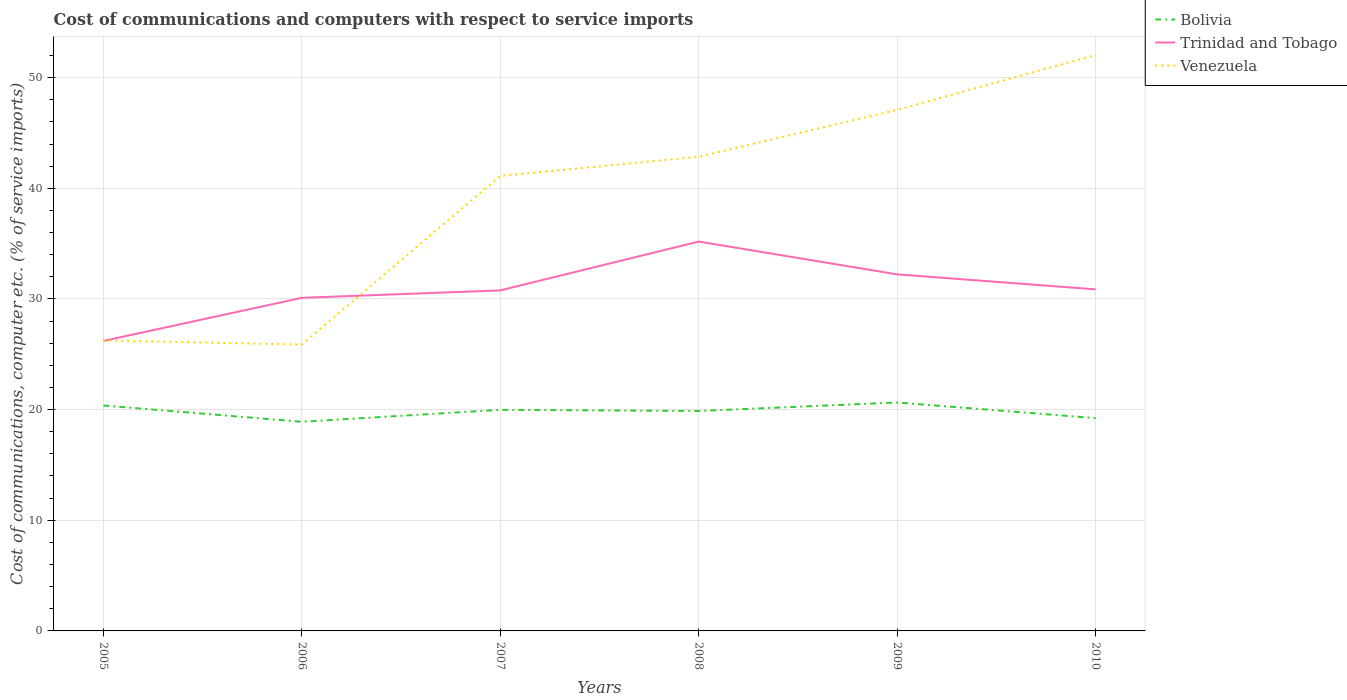Is the number of lines equal to the number of legend labels?
Your response must be concise. Yes. Across all years, what is the maximum cost of communications and computers in Bolivia?
Your answer should be very brief. 18.9. In which year was the cost of communications and computers in Trinidad and Tobago maximum?
Make the answer very short. 2005. What is the total cost of communications and computers in Venezuela in the graph?
Your answer should be very brief. -14.86. What is the difference between the highest and the second highest cost of communications and computers in Venezuela?
Make the answer very short. 26.18. What is the difference between the highest and the lowest cost of communications and computers in Venezuela?
Your answer should be compact. 4. Is the cost of communications and computers in Bolivia strictly greater than the cost of communications and computers in Venezuela over the years?
Keep it short and to the point. Yes. How many years are there in the graph?
Your answer should be compact. 6. What is the difference between two consecutive major ticks on the Y-axis?
Provide a succinct answer. 10. Are the values on the major ticks of Y-axis written in scientific E-notation?
Your answer should be compact. No. Does the graph contain grids?
Keep it short and to the point. Yes. Where does the legend appear in the graph?
Give a very brief answer. Top right. How are the legend labels stacked?
Keep it short and to the point. Vertical. What is the title of the graph?
Make the answer very short. Cost of communications and computers with respect to service imports. Does "Norway" appear as one of the legend labels in the graph?
Provide a short and direct response. No. What is the label or title of the X-axis?
Your response must be concise. Years. What is the label or title of the Y-axis?
Your response must be concise. Cost of communications, computer etc. (% of service imports). What is the Cost of communications, computer etc. (% of service imports) in Bolivia in 2005?
Give a very brief answer. 20.37. What is the Cost of communications, computer etc. (% of service imports) of Trinidad and Tobago in 2005?
Provide a short and direct response. 26.2. What is the Cost of communications, computer etc. (% of service imports) in Venezuela in 2005?
Your answer should be very brief. 26.25. What is the Cost of communications, computer etc. (% of service imports) in Bolivia in 2006?
Ensure brevity in your answer.  18.9. What is the Cost of communications, computer etc. (% of service imports) of Trinidad and Tobago in 2006?
Your answer should be very brief. 30.1. What is the Cost of communications, computer etc. (% of service imports) in Venezuela in 2006?
Your answer should be very brief. 25.88. What is the Cost of communications, computer etc. (% of service imports) in Bolivia in 2007?
Your response must be concise. 19.98. What is the Cost of communications, computer etc. (% of service imports) in Trinidad and Tobago in 2007?
Offer a terse response. 30.77. What is the Cost of communications, computer etc. (% of service imports) of Venezuela in 2007?
Give a very brief answer. 41.11. What is the Cost of communications, computer etc. (% of service imports) of Bolivia in 2008?
Provide a succinct answer. 19.88. What is the Cost of communications, computer etc. (% of service imports) of Trinidad and Tobago in 2008?
Provide a succinct answer. 35.18. What is the Cost of communications, computer etc. (% of service imports) in Venezuela in 2008?
Offer a very short reply. 42.85. What is the Cost of communications, computer etc. (% of service imports) in Bolivia in 2009?
Your answer should be very brief. 20.64. What is the Cost of communications, computer etc. (% of service imports) of Trinidad and Tobago in 2009?
Your response must be concise. 32.22. What is the Cost of communications, computer etc. (% of service imports) of Venezuela in 2009?
Keep it short and to the point. 47.09. What is the Cost of communications, computer etc. (% of service imports) in Bolivia in 2010?
Keep it short and to the point. 19.23. What is the Cost of communications, computer etc. (% of service imports) in Trinidad and Tobago in 2010?
Make the answer very short. 30.87. What is the Cost of communications, computer etc. (% of service imports) in Venezuela in 2010?
Give a very brief answer. 52.05. Across all years, what is the maximum Cost of communications, computer etc. (% of service imports) of Bolivia?
Provide a short and direct response. 20.64. Across all years, what is the maximum Cost of communications, computer etc. (% of service imports) in Trinidad and Tobago?
Offer a terse response. 35.18. Across all years, what is the maximum Cost of communications, computer etc. (% of service imports) of Venezuela?
Your answer should be very brief. 52.05. Across all years, what is the minimum Cost of communications, computer etc. (% of service imports) in Bolivia?
Offer a very short reply. 18.9. Across all years, what is the minimum Cost of communications, computer etc. (% of service imports) of Trinidad and Tobago?
Your response must be concise. 26.2. Across all years, what is the minimum Cost of communications, computer etc. (% of service imports) in Venezuela?
Offer a terse response. 25.88. What is the total Cost of communications, computer etc. (% of service imports) in Bolivia in the graph?
Your response must be concise. 119. What is the total Cost of communications, computer etc. (% of service imports) of Trinidad and Tobago in the graph?
Your response must be concise. 185.35. What is the total Cost of communications, computer etc. (% of service imports) of Venezuela in the graph?
Your answer should be compact. 235.23. What is the difference between the Cost of communications, computer etc. (% of service imports) in Bolivia in 2005 and that in 2006?
Keep it short and to the point. 1.47. What is the difference between the Cost of communications, computer etc. (% of service imports) in Trinidad and Tobago in 2005 and that in 2006?
Offer a very short reply. -3.9. What is the difference between the Cost of communications, computer etc. (% of service imports) in Venezuela in 2005 and that in 2006?
Offer a terse response. 0.37. What is the difference between the Cost of communications, computer etc. (% of service imports) of Bolivia in 2005 and that in 2007?
Your answer should be very brief. 0.39. What is the difference between the Cost of communications, computer etc. (% of service imports) in Trinidad and Tobago in 2005 and that in 2007?
Make the answer very short. -4.57. What is the difference between the Cost of communications, computer etc. (% of service imports) in Venezuela in 2005 and that in 2007?
Ensure brevity in your answer.  -14.86. What is the difference between the Cost of communications, computer etc. (% of service imports) of Bolivia in 2005 and that in 2008?
Your answer should be very brief. 0.5. What is the difference between the Cost of communications, computer etc. (% of service imports) in Trinidad and Tobago in 2005 and that in 2008?
Provide a succinct answer. -8.98. What is the difference between the Cost of communications, computer etc. (% of service imports) of Venezuela in 2005 and that in 2008?
Offer a very short reply. -16.6. What is the difference between the Cost of communications, computer etc. (% of service imports) of Bolivia in 2005 and that in 2009?
Ensure brevity in your answer.  -0.27. What is the difference between the Cost of communications, computer etc. (% of service imports) in Trinidad and Tobago in 2005 and that in 2009?
Give a very brief answer. -6.02. What is the difference between the Cost of communications, computer etc. (% of service imports) in Venezuela in 2005 and that in 2009?
Ensure brevity in your answer.  -20.84. What is the difference between the Cost of communications, computer etc. (% of service imports) of Bolivia in 2005 and that in 2010?
Your answer should be compact. 1.14. What is the difference between the Cost of communications, computer etc. (% of service imports) in Trinidad and Tobago in 2005 and that in 2010?
Your answer should be compact. -4.66. What is the difference between the Cost of communications, computer etc. (% of service imports) in Venezuela in 2005 and that in 2010?
Give a very brief answer. -25.8. What is the difference between the Cost of communications, computer etc. (% of service imports) in Bolivia in 2006 and that in 2007?
Your answer should be compact. -1.08. What is the difference between the Cost of communications, computer etc. (% of service imports) of Trinidad and Tobago in 2006 and that in 2007?
Your answer should be very brief. -0.67. What is the difference between the Cost of communications, computer etc. (% of service imports) in Venezuela in 2006 and that in 2007?
Provide a succinct answer. -15.24. What is the difference between the Cost of communications, computer etc. (% of service imports) in Bolivia in 2006 and that in 2008?
Offer a terse response. -0.98. What is the difference between the Cost of communications, computer etc. (% of service imports) of Trinidad and Tobago in 2006 and that in 2008?
Provide a succinct answer. -5.08. What is the difference between the Cost of communications, computer etc. (% of service imports) in Venezuela in 2006 and that in 2008?
Your response must be concise. -16.98. What is the difference between the Cost of communications, computer etc. (% of service imports) of Bolivia in 2006 and that in 2009?
Make the answer very short. -1.74. What is the difference between the Cost of communications, computer etc. (% of service imports) of Trinidad and Tobago in 2006 and that in 2009?
Offer a terse response. -2.12. What is the difference between the Cost of communications, computer etc. (% of service imports) in Venezuela in 2006 and that in 2009?
Your response must be concise. -21.21. What is the difference between the Cost of communications, computer etc. (% of service imports) of Bolivia in 2006 and that in 2010?
Ensure brevity in your answer.  -0.33. What is the difference between the Cost of communications, computer etc. (% of service imports) in Trinidad and Tobago in 2006 and that in 2010?
Ensure brevity in your answer.  -0.77. What is the difference between the Cost of communications, computer etc. (% of service imports) of Venezuela in 2006 and that in 2010?
Keep it short and to the point. -26.18. What is the difference between the Cost of communications, computer etc. (% of service imports) of Bolivia in 2007 and that in 2008?
Keep it short and to the point. 0.1. What is the difference between the Cost of communications, computer etc. (% of service imports) in Trinidad and Tobago in 2007 and that in 2008?
Make the answer very short. -4.41. What is the difference between the Cost of communications, computer etc. (% of service imports) of Venezuela in 2007 and that in 2008?
Keep it short and to the point. -1.74. What is the difference between the Cost of communications, computer etc. (% of service imports) of Bolivia in 2007 and that in 2009?
Give a very brief answer. -0.66. What is the difference between the Cost of communications, computer etc. (% of service imports) of Trinidad and Tobago in 2007 and that in 2009?
Give a very brief answer. -1.45. What is the difference between the Cost of communications, computer etc. (% of service imports) of Venezuela in 2007 and that in 2009?
Provide a short and direct response. -5.97. What is the difference between the Cost of communications, computer etc. (% of service imports) of Bolivia in 2007 and that in 2010?
Your answer should be compact. 0.75. What is the difference between the Cost of communications, computer etc. (% of service imports) in Trinidad and Tobago in 2007 and that in 2010?
Your answer should be compact. -0.09. What is the difference between the Cost of communications, computer etc. (% of service imports) of Venezuela in 2007 and that in 2010?
Keep it short and to the point. -10.94. What is the difference between the Cost of communications, computer etc. (% of service imports) of Bolivia in 2008 and that in 2009?
Ensure brevity in your answer.  -0.77. What is the difference between the Cost of communications, computer etc. (% of service imports) of Trinidad and Tobago in 2008 and that in 2009?
Your response must be concise. 2.96. What is the difference between the Cost of communications, computer etc. (% of service imports) in Venezuela in 2008 and that in 2009?
Give a very brief answer. -4.23. What is the difference between the Cost of communications, computer etc. (% of service imports) in Bolivia in 2008 and that in 2010?
Give a very brief answer. 0.65. What is the difference between the Cost of communications, computer etc. (% of service imports) of Trinidad and Tobago in 2008 and that in 2010?
Your answer should be very brief. 4.32. What is the difference between the Cost of communications, computer etc. (% of service imports) in Venezuela in 2008 and that in 2010?
Make the answer very short. -9.2. What is the difference between the Cost of communications, computer etc. (% of service imports) of Bolivia in 2009 and that in 2010?
Your response must be concise. 1.41. What is the difference between the Cost of communications, computer etc. (% of service imports) of Trinidad and Tobago in 2009 and that in 2010?
Provide a succinct answer. 1.35. What is the difference between the Cost of communications, computer etc. (% of service imports) of Venezuela in 2009 and that in 2010?
Provide a short and direct response. -4.96. What is the difference between the Cost of communications, computer etc. (% of service imports) in Bolivia in 2005 and the Cost of communications, computer etc. (% of service imports) in Trinidad and Tobago in 2006?
Keep it short and to the point. -9.73. What is the difference between the Cost of communications, computer etc. (% of service imports) in Bolivia in 2005 and the Cost of communications, computer etc. (% of service imports) in Venezuela in 2006?
Give a very brief answer. -5.5. What is the difference between the Cost of communications, computer etc. (% of service imports) of Trinidad and Tobago in 2005 and the Cost of communications, computer etc. (% of service imports) of Venezuela in 2006?
Your answer should be very brief. 0.33. What is the difference between the Cost of communications, computer etc. (% of service imports) of Bolivia in 2005 and the Cost of communications, computer etc. (% of service imports) of Trinidad and Tobago in 2007?
Your answer should be compact. -10.4. What is the difference between the Cost of communications, computer etc. (% of service imports) of Bolivia in 2005 and the Cost of communications, computer etc. (% of service imports) of Venezuela in 2007?
Make the answer very short. -20.74. What is the difference between the Cost of communications, computer etc. (% of service imports) of Trinidad and Tobago in 2005 and the Cost of communications, computer etc. (% of service imports) of Venezuela in 2007?
Provide a succinct answer. -14.91. What is the difference between the Cost of communications, computer etc. (% of service imports) in Bolivia in 2005 and the Cost of communications, computer etc. (% of service imports) in Trinidad and Tobago in 2008?
Keep it short and to the point. -14.81. What is the difference between the Cost of communications, computer etc. (% of service imports) of Bolivia in 2005 and the Cost of communications, computer etc. (% of service imports) of Venezuela in 2008?
Give a very brief answer. -22.48. What is the difference between the Cost of communications, computer etc. (% of service imports) of Trinidad and Tobago in 2005 and the Cost of communications, computer etc. (% of service imports) of Venezuela in 2008?
Provide a short and direct response. -16.65. What is the difference between the Cost of communications, computer etc. (% of service imports) in Bolivia in 2005 and the Cost of communications, computer etc. (% of service imports) in Trinidad and Tobago in 2009?
Your answer should be very brief. -11.85. What is the difference between the Cost of communications, computer etc. (% of service imports) in Bolivia in 2005 and the Cost of communications, computer etc. (% of service imports) in Venezuela in 2009?
Give a very brief answer. -26.71. What is the difference between the Cost of communications, computer etc. (% of service imports) in Trinidad and Tobago in 2005 and the Cost of communications, computer etc. (% of service imports) in Venezuela in 2009?
Give a very brief answer. -20.88. What is the difference between the Cost of communications, computer etc. (% of service imports) of Bolivia in 2005 and the Cost of communications, computer etc. (% of service imports) of Trinidad and Tobago in 2010?
Provide a short and direct response. -10.49. What is the difference between the Cost of communications, computer etc. (% of service imports) of Bolivia in 2005 and the Cost of communications, computer etc. (% of service imports) of Venezuela in 2010?
Offer a very short reply. -31.68. What is the difference between the Cost of communications, computer etc. (% of service imports) in Trinidad and Tobago in 2005 and the Cost of communications, computer etc. (% of service imports) in Venezuela in 2010?
Your answer should be very brief. -25.85. What is the difference between the Cost of communications, computer etc. (% of service imports) of Bolivia in 2006 and the Cost of communications, computer etc. (% of service imports) of Trinidad and Tobago in 2007?
Your answer should be very brief. -11.87. What is the difference between the Cost of communications, computer etc. (% of service imports) of Bolivia in 2006 and the Cost of communications, computer etc. (% of service imports) of Venezuela in 2007?
Provide a succinct answer. -22.21. What is the difference between the Cost of communications, computer etc. (% of service imports) in Trinidad and Tobago in 2006 and the Cost of communications, computer etc. (% of service imports) in Venezuela in 2007?
Keep it short and to the point. -11.01. What is the difference between the Cost of communications, computer etc. (% of service imports) in Bolivia in 2006 and the Cost of communications, computer etc. (% of service imports) in Trinidad and Tobago in 2008?
Provide a succinct answer. -16.28. What is the difference between the Cost of communications, computer etc. (% of service imports) in Bolivia in 2006 and the Cost of communications, computer etc. (% of service imports) in Venezuela in 2008?
Offer a very short reply. -23.95. What is the difference between the Cost of communications, computer etc. (% of service imports) in Trinidad and Tobago in 2006 and the Cost of communications, computer etc. (% of service imports) in Venezuela in 2008?
Offer a very short reply. -12.75. What is the difference between the Cost of communications, computer etc. (% of service imports) of Bolivia in 2006 and the Cost of communications, computer etc. (% of service imports) of Trinidad and Tobago in 2009?
Your answer should be very brief. -13.32. What is the difference between the Cost of communications, computer etc. (% of service imports) of Bolivia in 2006 and the Cost of communications, computer etc. (% of service imports) of Venezuela in 2009?
Make the answer very short. -28.19. What is the difference between the Cost of communications, computer etc. (% of service imports) in Trinidad and Tobago in 2006 and the Cost of communications, computer etc. (% of service imports) in Venezuela in 2009?
Your answer should be compact. -16.99. What is the difference between the Cost of communications, computer etc. (% of service imports) in Bolivia in 2006 and the Cost of communications, computer etc. (% of service imports) in Trinidad and Tobago in 2010?
Offer a very short reply. -11.97. What is the difference between the Cost of communications, computer etc. (% of service imports) of Bolivia in 2006 and the Cost of communications, computer etc. (% of service imports) of Venezuela in 2010?
Provide a succinct answer. -33.15. What is the difference between the Cost of communications, computer etc. (% of service imports) in Trinidad and Tobago in 2006 and the Cost of communications, computer etc. (% of service imports) in Venezuela in 2010?
Ensure brevity in your answer.  -21.95. What is the difference between the Cost of communications, computer etc. (% of service imports) of Bolivia in 2007 and the Cost of communications, computer etc. (% of service imports) of Trinidad and Tobago in 2008?
Your answer should be very brief. -15.21. What is the difference between the Cost of communications, computer etc. (% of service imports) of Bolivia in 2007 and the Cost of communications, computer etc. (% of service imports) of Venezuela in 2008?
Your response must be concise. -22.87. What is the difference between the Cost of communications, computer etc. (% of service imports) in Trinidad and Tobago in 2007 and the Cost of communications, computer etc. (% of service imports) in Venezuela in 2008?
Your answer should be compact. -12.08. What is the difference between the Cost of communications, computer etc. (% of service imports) in Bolivia in 2007 and the Cost of communications, computer etc. (% of service imports) in Trinidad and Tobago in 2009?
Offer a very short reply. -12.24. What is the difference between the Cost of communications, computer etc. (% of service imports) of Bolivia in 2007 and the Cost of communications, computer etc. (% of service imports) of Venezuela in 2009?
Offer a terse response. -27.11. What is the difference between the Cost of communications, computer etc. (% of service imports) of Trinidad and Tobago in 2007 and the Cost of communications, computer etc. (% of service imports) of Venezuela in 2009?
Give a very brief answer. -16.31. What is the difference between the Cost of communications, computer etc. (% of service imports) of Bolivia in 2007 and the Cost of communications, computer etc. (% of service imports) of Trinidad and Tobago in 2010?
Give a very brief answer. -10.89. What is the difference between the Cost of communications, computer etc. (% of service imports) in Bolivia in 2007 and the Cost of communications, computer etc. (% of service imports) in Venezuela in 2010?
Offer a very short reply. -32.07. What is the difference between the Cost of communications, computer etc. (% of service imports) in Trinidad and Tobago in 2007 and the Cost of communications, computer etc. (% of service imports) in Venezuela in 2010?
Your response must be concise. -21.28. What is the difference between the Cost of communications, computer etc. (% of service imports) of Bolivia in 2008 and the Cost of communications, computer etc. (% of service imports) of Trinidad and Tobago in 2009?
Provide a succinct answer. -12.34. What is the difference between the Cost of communications, computer etc. (% of service imports) in Bolivia in 2008 and the Cost of communications, computer etc. (% of service imports) in Venezuela in 2009?
Your answer should be very brief. -27.21. What is the difference between the Cost of communications, computer etc. (% of service imports) of Trinidad and Tobago in 2008 and the Cost of communications, computer etc. (% of service imports) of Venezuela in 2009?
Your answer should be very brief. -11.9. What is the difference between the Cost of communications, computer etc. (% of service imports) of Bolivia in 2008 and the Cost of communications, computer etc. (% of service imports) of Trinidad and Tobago in 2010?
Your answer should be very brief. -10.99. What is the difference between the Cost of communications, computer etc. (% of service imports) of Bolivia in 2008 and the Cost of communications, computer etc. (% of service imports) of Venezuela in 2010?
Offer a terse response. -32.18. What is the difference between the Cost of communications, computer etc. (% of service imports) of Trinidad and Tobago in 2008 and the Cost of communications, computer etc. (% of service imports) of Venezuela in 2010?
Your answer should be compact. -16.87. What is the difference between the Cost of communications, computer etc. (% of service imports) of Bolivia in 2009 and the Cost of communications, computer etc. (% of service imports) of Trinidad and Tobago in 2010?
Provide a short and direct response. -10.22. What is the difference between the Cost of communications, computer etc. (% of service imports) of Bolivia in 2009 and the Cost of communications, computer etc. (% of service imports) of Venezuela in 2010?
Provide a succinct answer. -31.41. What is the difference between the Cost of communications, computer etc. (% of service imports) of Trinidad and Tobago in 2009 and the Cost of communications, computer etc. (% of service imports) of Venezuela in 2010?
Your answer should be very brief. -19.83. What is the average Cost of communications, computer etc. (% of service imports) of Bolivia per year?
Ensure brevity in your answer.  19.83. What is the average Cost of communications, computer etc. (% of service imports) of Trinidad and Tobago per year?
Your answer should be very brief. 30.89. What is the average Cost of communications, computer etc. (% of service imports) in Venezuela per year?
Your response must be concise. 39.2. In the year 2005, what is the difference between the Cost of communications, computer etc. (% of service imports) of Bolivia and Cost of communications, computer etc. (% of service imports) of Trinidad and Tobago?
Your answer should be compact. -5.83. In the year 2005, what is the difference between the Cost of communications, computer etc. (% of service imports) of Bolivia and Cost of communications, computer etc. (% of service imports) of Venezuela?
Your response must be concise. -5.88. In the year 2005, what is the difference between the Cost of communications, computer etc. (% of service imports) of Trinidad and Tobago and Cost of communications, computer etc. (% of service imports) of Venezuela?
Your response must be concise. -0.05. In the year 2006, what is the difference between the Cost of communications, computer etc. (% of service imports) of Bolivia and Cost of communications, computer etc. (% of service imports) of Trinidad and Tobago?
Ensure brevity in your answer.  -11.2. In the year 2006, what is the difference between the Cost of communications, computer etc. (% of service imports) of Bolivia and Cost of communications, computer etc. (% of service imports) of Venezuela?
Ensure brevity in your answer.  -6.98. In the year 2006, what is the difference between the Cost of communications, computer etc. (% of service imports) in Trinidad and Tobago and Cost of communications, computer etc. (% of service imports) in Venezuela?
Keep it short and to the point. 4.22. In the year 2007, what is the difference between the Cost of communications, computer etc. (% of service imports) of Bolivia and Cost of communications, computer etc. (% of service imports) of Trinidad and Tobago?
Ensure brevity in your answer.  -10.79. In the year 2007, what is the difference between the Cost of communications, computer etc. (% of service imports) of Bolivia and Cost of communications, computer etc. (% of service imports) of Venezuela?
Provide a short and direct response. -21.13. In the year 2007, what is the difference between the Cost of communications, computer etc. (% of service imports) in Trinidad and Tobago and Cost of communications, computer etc. (% of service imports) in Venezuela?
Keep it short and to the point. -10.34. In the year 2008, what is the difference between the Cost of communications, computer etc. (% of service imports) of Bolivia and Cost of communications, computer etc. (% of service imports) of Trinidad and Tobago?
Keep it short and to the point. -15.31. In the year 2008, what is the difference between the Cost of communications, computer etc. (% of service imports) in Bolivia and Cost of communications, computer etc. (% of service imports) in Venezuela?
Ensure brevity in your answer.  -22.98. In the year 2008, what is the difference between the Cost of communications, computer etc. (% of service imports) of Trinidad and Tobago and Cost of communications, computer etc. (% of service imports) of Venezuela?
Your answer should be compact. -7.67. In the year 2009, what is the difference between the Cost of communications, computer etc. (% of service imports) of Bolivia and Cost of communications, computer etc. (% of service imports) of Trinidad and Tobago?
Give a very brief answer. -11.58. In the year 2009, what is the difference between the Cost of communications, computer etc. (% of service imports) in Bolivia and Cost of communications, computer etc. (% of service imports) in Venezuela?
Your answer should be compact. -26.44. In the year 2009, what is the difference between the Cost of communications, computer etc. (% of service imports) in Trinidad and Tobago and Cost of communications, computer etc. (% of service imports) in Venezuela?
Your answer should be compact. -14.87. In the year 2010, what is the difference between the Cost of communications, computer etc. (% of service imports) in Bolivia and Cost of communications, computer etc. (% of service imports) in Trinidad and Tobago?
Offer a terse response. -11.64. In the year 2010, what is the difference between the Cost of communications, computer etc. (% of service imports) of Bolivia and Cost of communications, computer etc. (% of service imports) of Venezuela?
Ensure brevity in your answer.  -32.82. In the year 2010, what is the difference between the Cost of communications, computer etc. (% of service imports) in Trinidad and Tobago and Cost of communications, computer etc. (% of service imports) in Venezuela?
Keep it short and to the point. -21.19. What is the ratio of the Cost of communications, computer etc. (% of service imports) in Bolivia in 2005 to that in 2006?
Offer a terse response. 1.08. What is the ratio of the Cost of communications, computer etc. (% of service imports) of Trinidad and Tobago in 2005 to that in 2006?
Offer a terse response. 0.87. What is the ratio of the Cost of communications, computer etc. (% of service imports) in Venezuela in 2005 to that in 2006?
Provide a short and direct response. 1.01. What is the ratio of the Cost of communications, computer etc. (% of service imports) in Bolivia in 2005 to that in 2007?
Your answer should be compact. 1.02. What is the ratio of the Cost of communications, computer etc. (% of service imports) in Trinidad and Tobago in 2005 to that in 2007?
Provide a succinct answer. 0.85. What is the ratio of the Cost of communications, computer etc. (% of service imports) in Venezuela in 2005 to that in 2007?
Provide a short and direct response. 0.64. What is the ratio of the Cost of communications, computer etc. (% of service imports) in Bolivia in 2005 to that in 2008?
Your answer should be compact. 1.02. What is the ratio of the Cost of communications, computer etc. (% of service imports) of Trinidad and Tobago in 2005 to that in 2008?
Make the answer very short. 0.74. What is the ratio of the Cost of communications, computer etc. (% of service imports) in Venezuela in 2005 to that in 2008?
Provide a short and direct response. 0.61. What is the ratio of the Cost of communications, computer etc. (% of service imports) of Bolivia in 2005 to that in 2009?
Provide a short and direct response. 0.99. What is the ratio of the Cost of communications, computer etc. (% of service imports) of Trinidad and Tobago in 2005 to that in 2009?
Offer a very short reply. 0.81. What is the ratio of the Cost of communications, computer etc. (% of service imports) of Venezuela in 2005 to that in 2009?
Keep it short and to the point. 0.56. What is the ratio of the Cost of communications, computer etc. (% of service imports) of Bolivia in 2005 to that in 2010?
Provide a short and direct response. 1.06. What is the ratio of the Cost of communications, computer etc. (% of service imports) of Trinidad and Tobago in 2005 to that in 2010?
Offer a terse response. 0.85. What is the ratio of the Cost of communications, computer etc. (% of service imports) of Venezuela in 2005 to that in 2010?
Ensure brevity in your answer.  0.5. What is the ratio of the Cost of communications, computer etc. (% of service imports) in Bolivia in 2006 to that in 2007?
Keep it short and to the point. 0.95. What is the ratio of the Cost of communications, computer etc. (% of service imports) of Trinidad and Tobago in 2006 to that in 2007?
Offer a very short reply. 0.98. What is the ratio of the Cost of communications, computer etc. (% of service imports) in Venezuela in 2006 to that in 2007?
Give a very brief answer. 0.63. What is the ratio of the Cost of communications, computer etc. (% of service imports) of Bolivia in 2006 to that in 2008?
Ensure brevity in your answer.  0.95. What is the ratio of the Cost of communications, computer etc. (% of service imports) of Trinidad and Tobago in 2006 to that in 2008?
Your answer should be very brief. 0.86. What is the ratio of the Cost of communications, computer etc. (% of service imports) of Venezuela in 2006 to that in 2008?
Give a very brief answer. 0.6. What is the ratio of the Cost of communications, computer etc. (% of service imports) of Bolivia in 2006 to that in 2009?
Offer a very short reply. 0.92. What is the ratio of the Cost of communications, computer etc. (% of service imports) of Trinidad and Tobago in 2006 to that in 2009?
Your response must be concise. 0.93. What is the ratio of the Cost of communications, computer etc. (% of service imports) in Venezuela in 2006 to that in 2009?
Ensure brevity in your answer.  0.55. What is the ratio of the Cost of communications, computer etc. (% of service imports) of Bolivia in 2006 to that in 2010?
Your answer should be compact. 0.98. What is the ratio of the Cost of communications, computer etc. (% of service imports) in Trinidad and Tobago in 2006 to that in 2010?
Keep it short and to the point. 0.98. What is the ratio of the Cost of communications, computer etc. (% of service imports) of Venezuela in 2006 to that in 2010?
Provide a short and direct response. 0.5. What is the ratio of the Cost of communications, computer etc. (% of service imports) of Trinidad and Tobago in 2007 to that in 2008?
Make the answer very short. 0.87. What is the ratio of the Cost of communications, computer etc. (% of service imports) of Venezuela in 2007 to that in 2008?
Offer a terse response. 0.96. What is the ratio of the Cost of communications, computer etc. (% of service imports) of Bolivia in 2007 to that in 2009?
Your answer should be compact. 0.97. What is the ratio of the Cost of communications, computer etc. (% of service imports) in Trinidad and Tobago in 2007 to that in 2009?
Offer a very short reply. 0.96. What is the ratio of the Cost of communications, computer etc. (% of service imports) in Venezuela in 2007 to that in 2009?
Provide a short and direct response. 0.87. What is the ratio of the Cost of communications, computer etc. (% of service imports) of Bolivia in 2007 to that in 2010?
Your response must be concise. 1.04. What is the ratio of the Cost of communications, computer etc. (% of service imports) in Trinidad and Tobago in 2007 to that in 2010?
Make the answer very short. 1. What is the ratio of the Cost of communications, computer etc. (% of service imports) in Venezuela in 2007 to that in 2010?
Offer a very short reply. 0.79. What is the ratio of the Cost of communications, computer etc. (% of service imports) in Bolivia in 2008 to that in 2009?
Provide a succinct answer. 0.96. What is the ratio of the Cost of communications, computer etc. (% of service imports) in Trinidad and Tobago in 2008 to that in 2009?
Your answer should be compact. 1.09. What is the ratio of the Cost of communications, computer etc. (% of service imports) in Venezuela in 2008 to that in 2009?
Keep it short and to the point. 0.91. What is the ratio of the Cost of communications, computer etc. (% of service imports) in Bolivia in 2008 to that in 2010?
Offer a very short reply. 1.03. What is the ratio of the Cost of communications, computer etc. (% of service imports) in Trinidad and Tobago in 2008 to that in 2010?
Keep it short and to the point. 1.14. What is the ratio of the Cost of communications, computer etc. (% of service imports) of Venezuela in 2008 to that in 2010?
Offer a very short reply. 0.82. What is the ratio of the Cost of communications, computer etc. (% of service imports) in Bolivia in 2009 to that in 2010?
Ensure brevity in your answer.  1.07. What is the ratio of the Cost of communications, computer etc. (% of service imports) in Trinidad and Tobago in 2009 to that in 2010?
Your answer should be compact. 1.04. What is the ratio of the Cost of communications, computer etc. (% of service imports) in Venezuela in 2009 to that in 2010?
Make the answer very short. 0.9. What is the difference between the highest and the second highest Cost of communications, computer etc. (% of service imports) in Bolivia?
Keep it short and to the point. 0.27. What is the difference between the highest and the second highest Cost of communications, computer etc. (% of service imports) of Trinidad and Tobago?
Provide a short and direct response. 2.96. What is the difference between the highest and the second highest Cost of communications, computer etc. (% of service imports) of Venezuela?
Offer a very short reply. 4.96. What is the difference between the highest and the lowest Cost of communications, computer etc. (% of service imports) in Bolivia?
Keep it short and to the point. 1.74. What is the difference between the highest and the lowest Cost of communications, computer etc. (% of service imports) of Trinidad and Tobago?
Offer a terse response. 8.98. What is the difference between the highest and the lowest Cost of communications, computer etc. (% of service imports) of Venezuela?
Your answer should be compact. 26.18. 